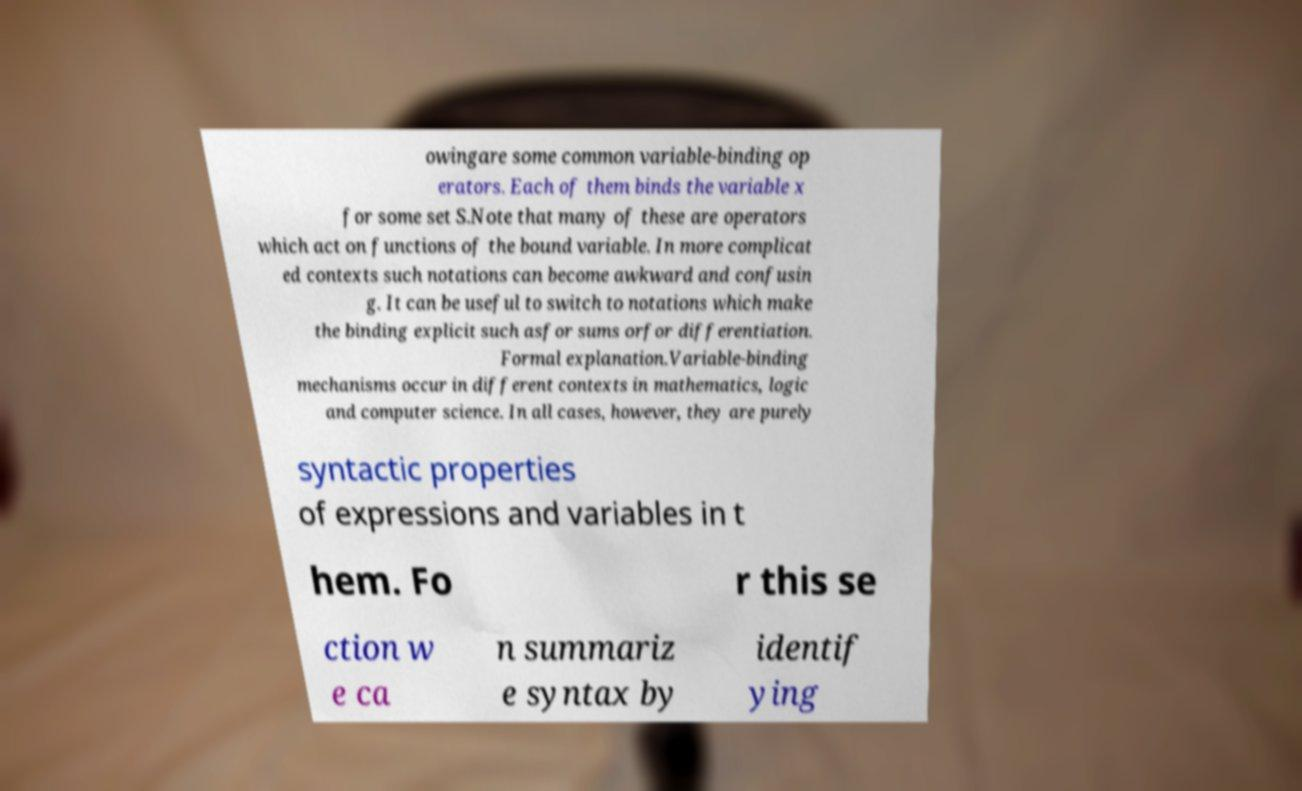Could you extract and type out the text from this image? owingare some common variable-binding op erators. Each of them binds the variable x for some set S.Note that many of these are operators which act on functions of the bound variable. In more complicat ed contexts such notations can become awkward and confusin g. It can be useful to switch to notations which make the binding explicit such asfor sums orfor differentiation. Formal explanation.Variable-binding mechanisms occur in different contexts in mathematics, logic and computer science. In all cases, however, they are purely syntactic properties of expressions and variables in t hem. Fo r this se ction w e ca n summariz e syntax by identif ying 